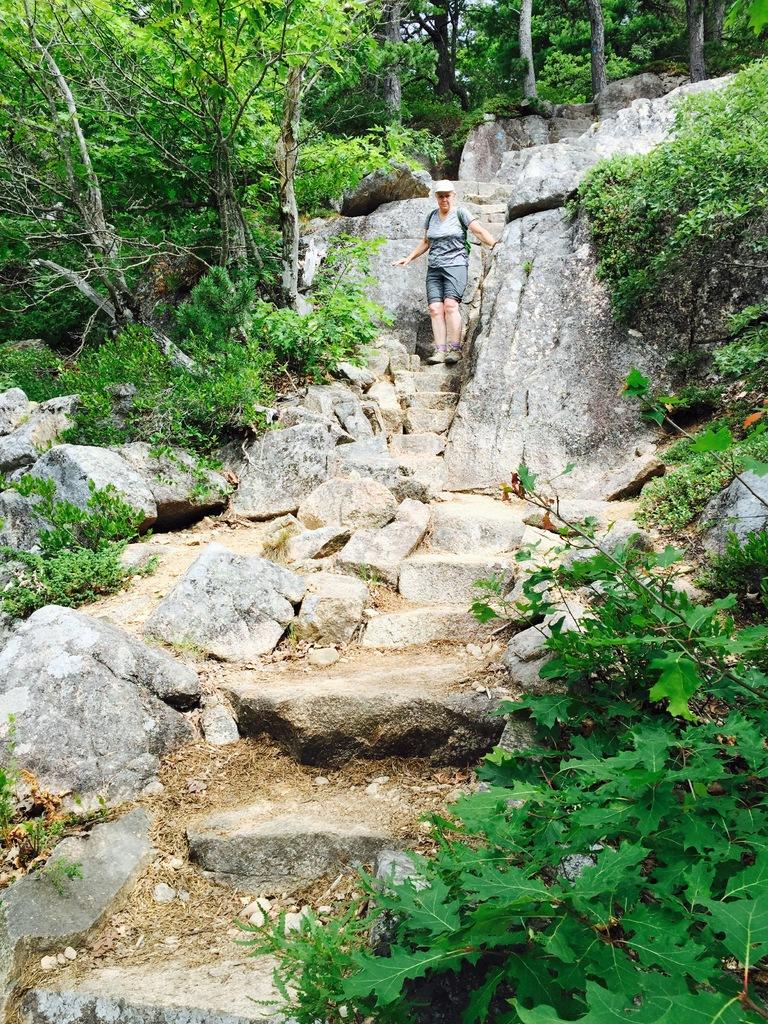What is the main subject of the image? There is a person in the image. What can be seen in the background of the image? There are steps on a hill in the image. What type of natural elements are present in the image? Rocks, plants, and trees are present in the image. How many frogs can be seen sitting on the yoke in the image? There are no frogs or yokes present in the image. 